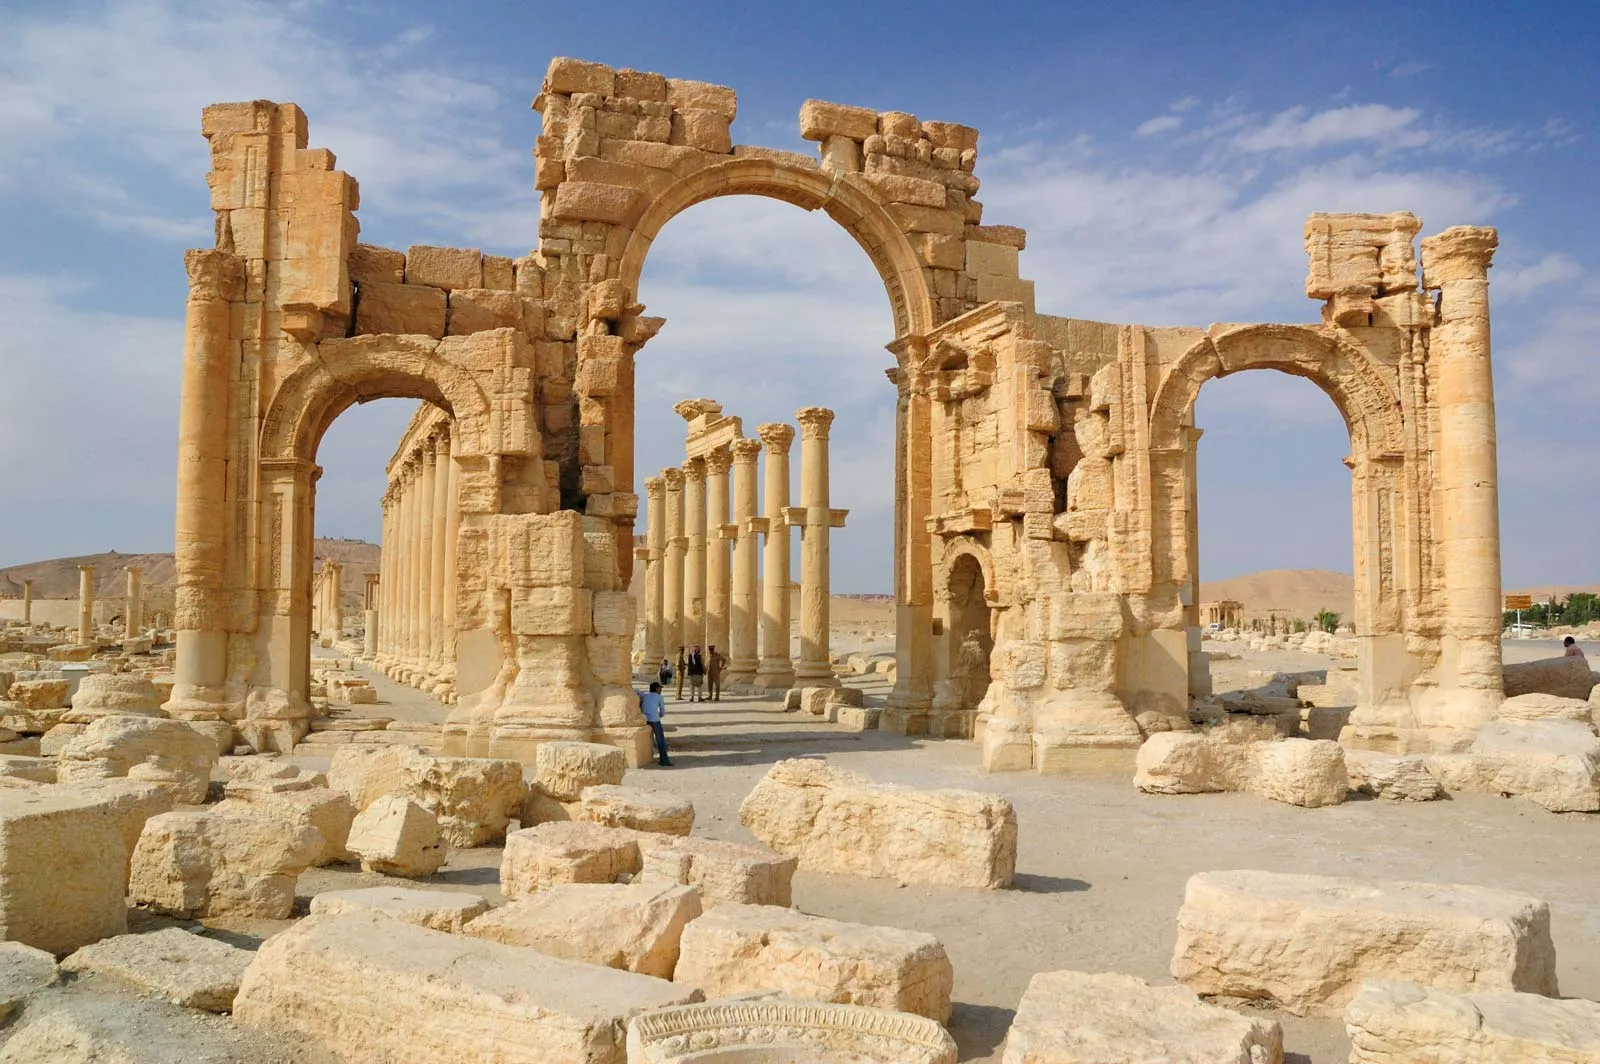Analyze the image in a comprehensive and detailed manner. The image showcases the spectacular ruins of Palmyra, an ancient city located in Syria. Prominently featured in the foreground is the monumental arch, a stunning example of the architectural mastery of ancient civilizations. This arch, made from weathered sandstone, includes three distinct passageways, with the central arch standing taller and more grandiose than the flanking arches. Each passageway is intricately detailed with carvings that exhibit both artistic flair and historical significance.

Behind and around the arch, remnants of once-majestic columns and ruins are scattered across the arid landscape, hinting at the ancient city's former magnificence and bustling activity. The columns, though many are now broken, still stand upright, framing the pathways that were likely significant thoroughfares during the city's prime. The clear blue sky overhead contrasts beautifully with the warm hues of the sandstone, enhancing the ancient structure's grandeur. The photograph, taken on a bright and sunny day, bathes the ruins in a soft, golden light that further accentuates their intricate details. The image provides a poignant glimpse into the rich history and enduring legacy of Palmyra, drawing the viewer into a deeper appreciation of its historical and cultural importance. 